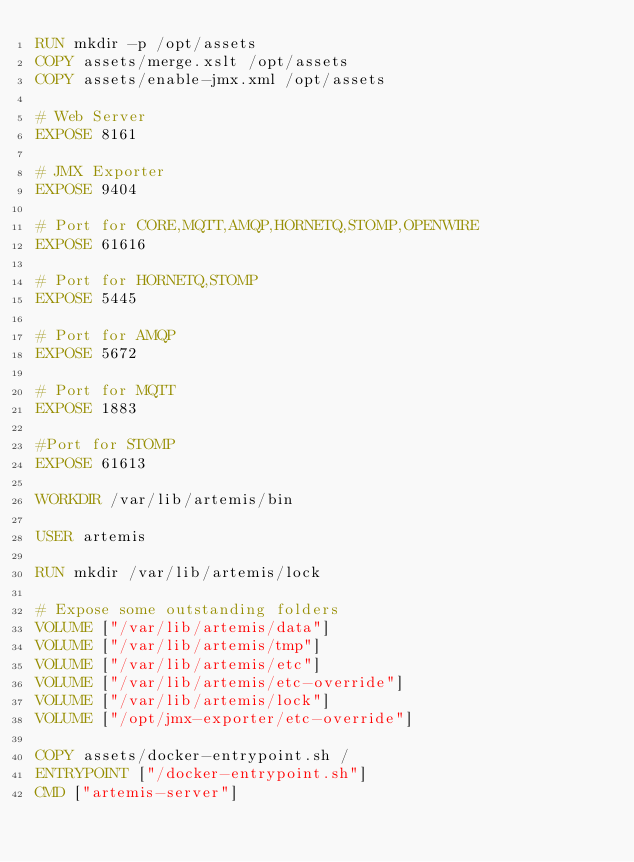Convert code to text. <code><loc_0><loc_0><loc_500><loc_500><_Dockerfile_>RUN mkdir -p /opt/assets
COPY assets/merge.xslt /opt/assets
COPY assets/enable-jmx.xml /opt/assets

# Web Server
EXPOSE 8161

# JMX Exporter
EXPOSE 9404

# Port for CORE,MQTT,AMQP,HORNETQ,STOMP,OPENWIRE
EXPOSE 61616

# Port for HORNETQ,STOMP
EXPOSE 5445

# Port for AMQP
EXPOSE 5672

# Port for MQTT
EXPOSE 1883

#Port for STOMP
EXPOSE 61613

WORKDIR /var/lib/artemis/bin

USER artemis

RUN mkdir /var/lib/artemis/lock

# Expose some outstanding folders
VOLUME ["/var/lib/artemis/data"]
VOLUME ["/var/lib/artemis/tmp"]
VOLUME ["/var/lib/artemis/etc"]
VOLUME ["/var/lib/artemis/etc-override"]
VOLUME ["/var/lib/artemis/lock"]
VOLUME ["/opt/jmx-exporter/etc-override"]

COPY assets/docker-entrypoint.sh /
ENTRYPOINT ["/docker-entrypoint.sh"]
CMD ["artemis-server"]
</code> 